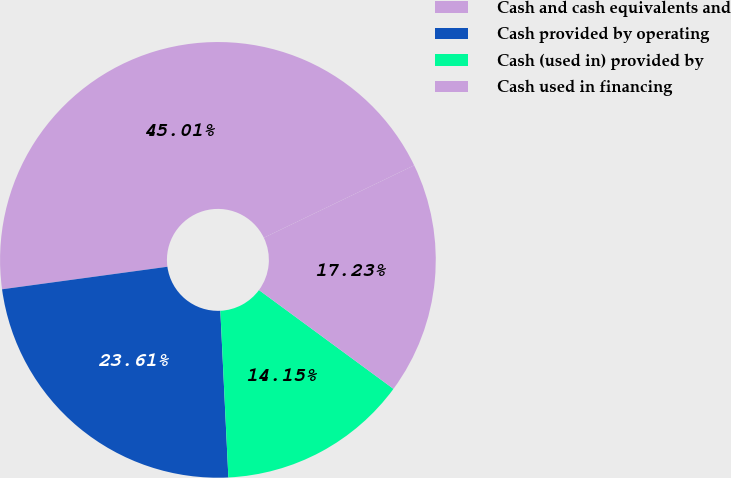<chart> <loc_0><loc_0><loc_500><loc_500><pie_chart><fcel>Cash and cash equivalents and<fcel>Cash provided by operating<fcel>Cash (used in) provided by<fcel>Cash used in financing<nl><fcel>45.01%<fcel>23.61%<fcel>14.15%<fcel>17.23%<nl></chart> 